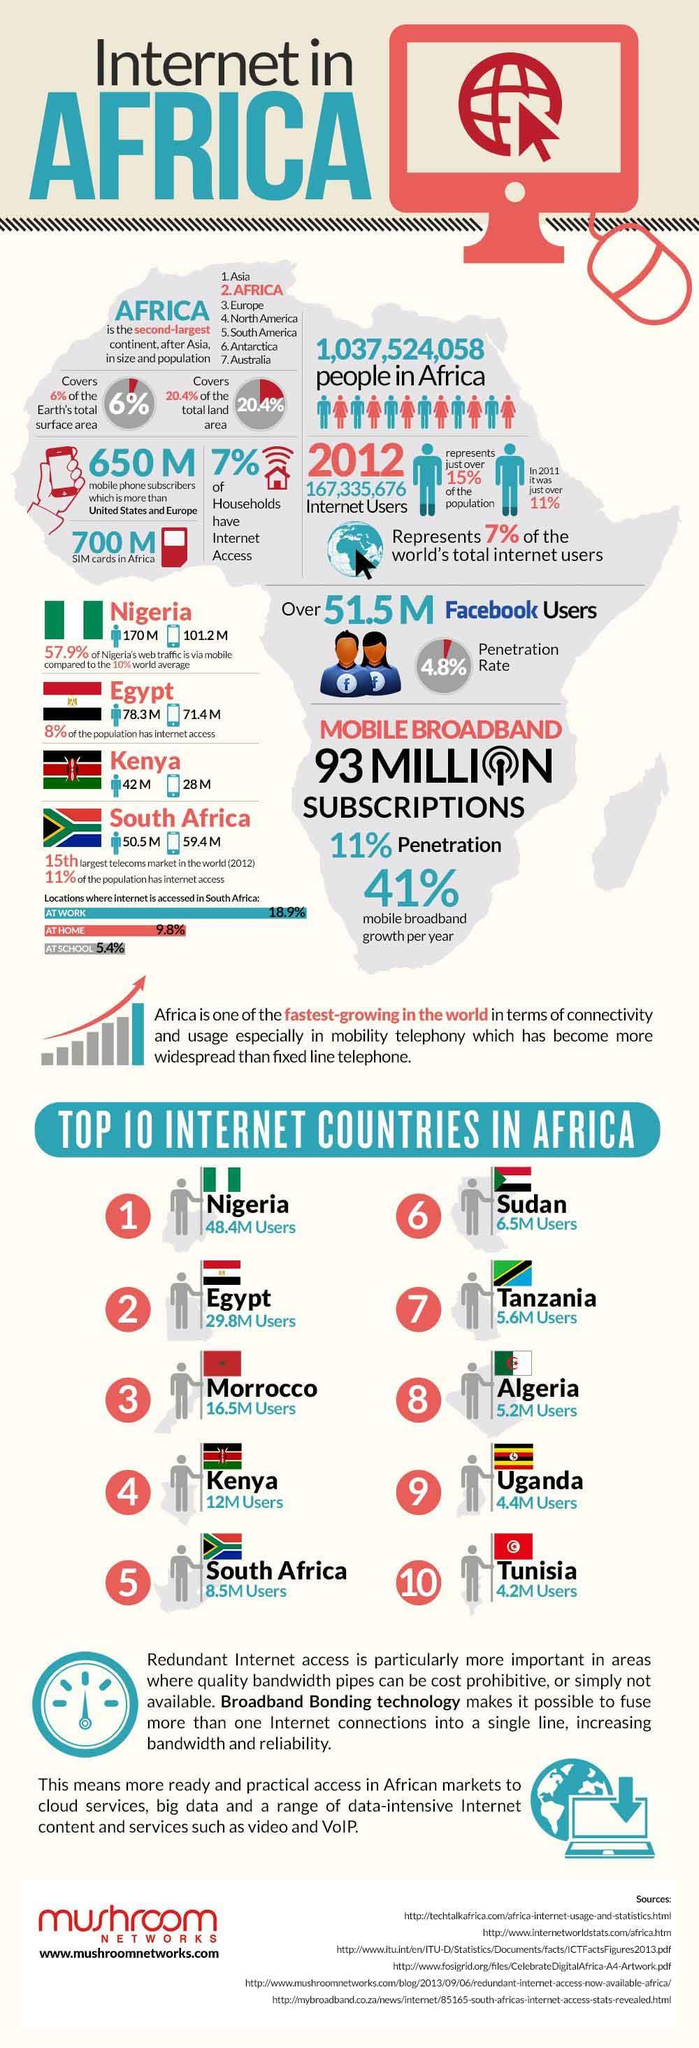What is the number of SIM cards available in Africa in 2012?
Answer the question with a short phrase. 700 M Which African country has the third highest number of internet users among the top countries in 2012? Morrocco How many people in Nigeria access to the internet through mobile in 2012? 101.2 M Which African country has the second highest number of internet users among the top countries in 2012? Egypt What is the number of internet users in Uganda in 2012? 4.4M Users What percentage of households in Africa has internet access in 2012? 7% How many people in Kenya access to the internet through mobile in 2012? 28 M What is the total number of internet users in Africa in 2012? 167,335,676 